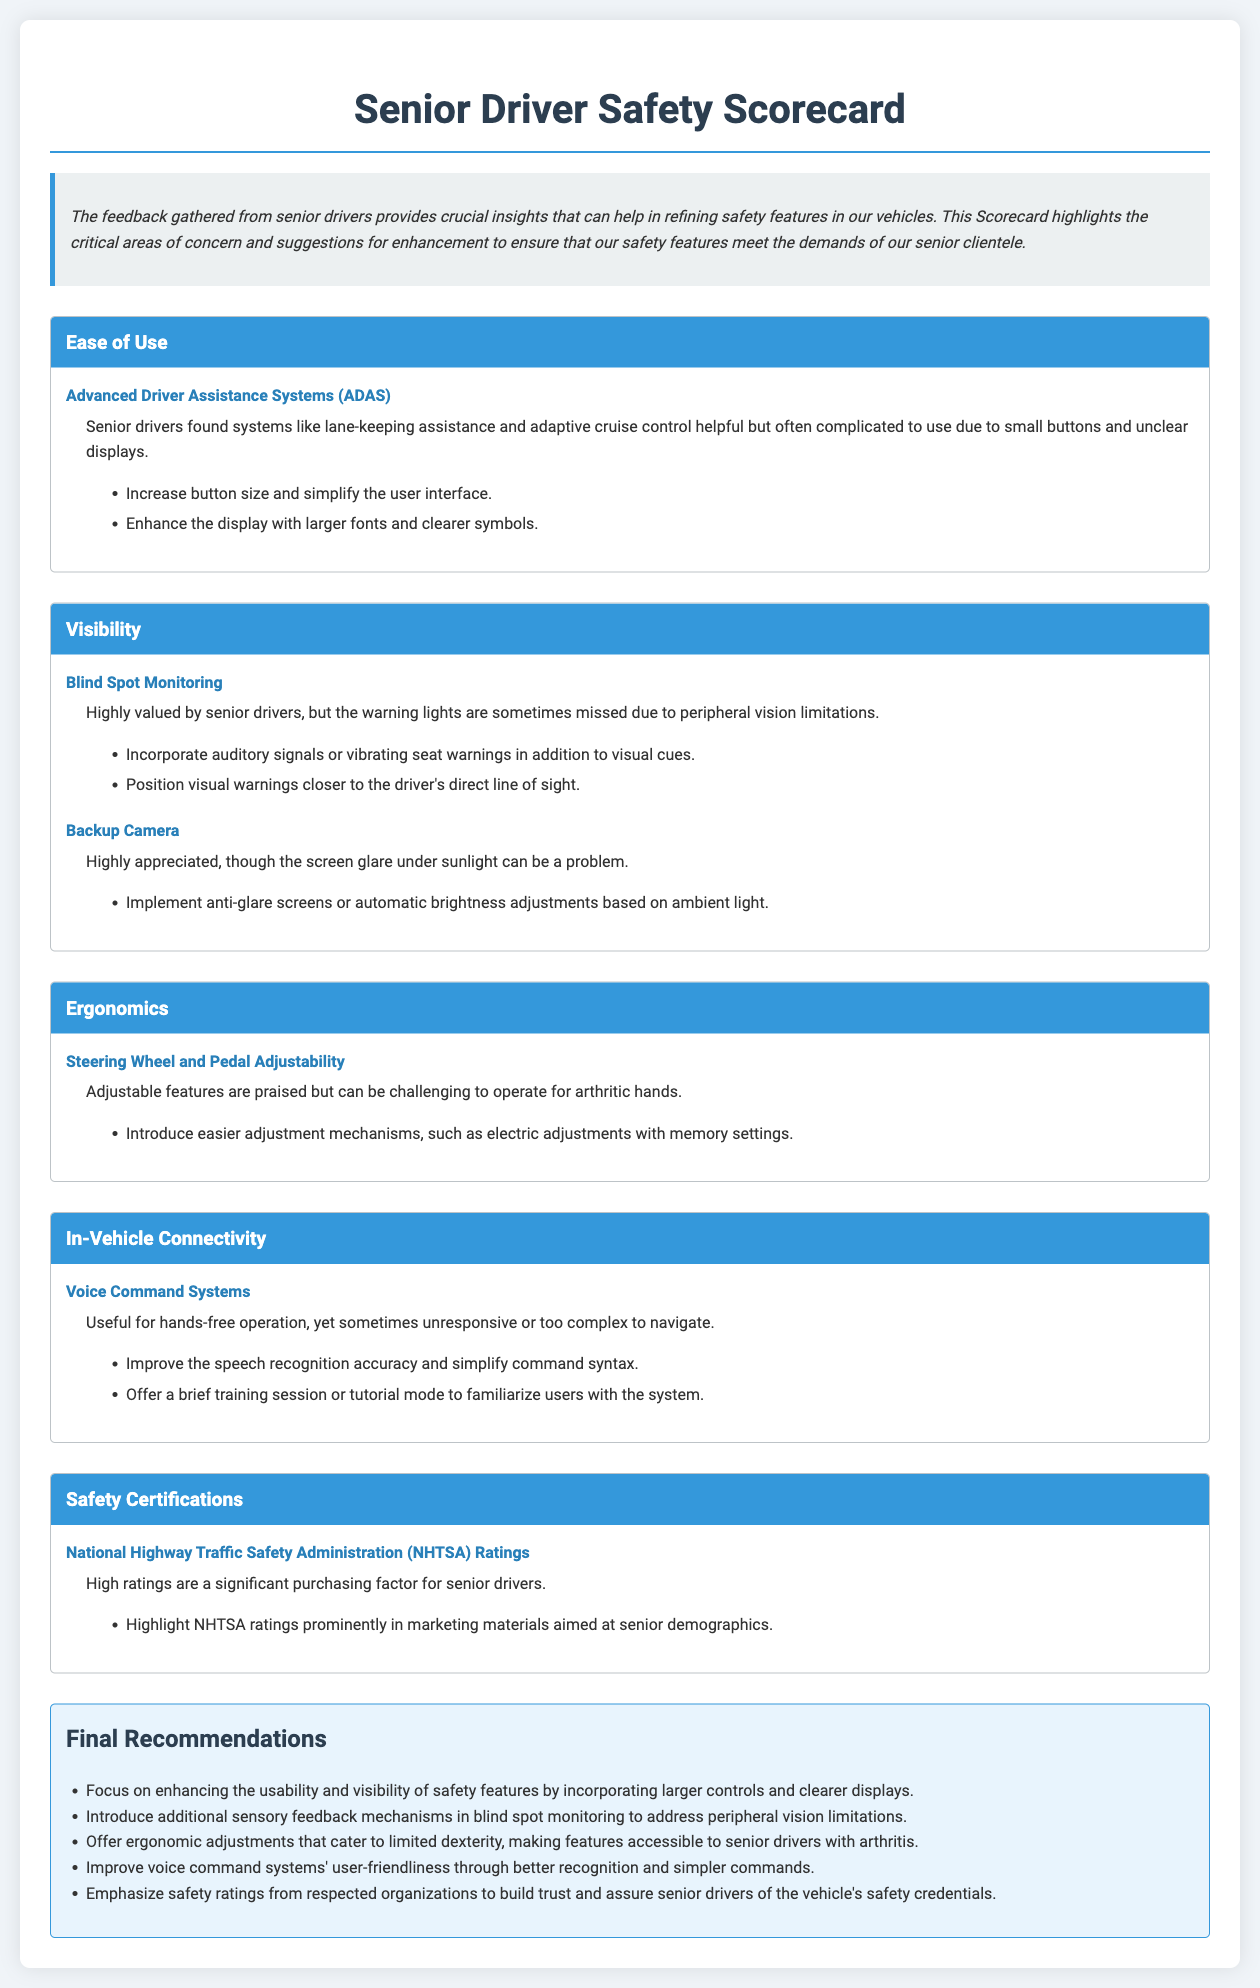what is the main purpose of the Scorecard? The purpose of the Scorecard is to highlight critical areas of concern and suggestions for enhancement to ensure that safety features meet the demands of senior clientele.
Answer: to refine safety features for senior clientele which safety feature received feedback regarding button size and display clarity? Advanced Driver Assistance Systems received feedback about the complexity of use due to small buttons and unclear displays.
Answer: Advanced Driver Assistance Systems what suggestion was made for Blind Spot Monitoring? A suggestion made was to incorporate auditory signals or vibrating seat warnings in addition to visual cues.
Answer: incorporate auditory signals or vibrating seat warnings how do senior drivers feel about the Backup Camera? Senior drivers highly appreciated the Backup Camera, despite the issue with screen glare under sunlight.
Answer: highly appreciated what is emphasized in the final recommendations regarding usability? The final recommendations emphasize enhancing the usability of safety features by incorporating larger controls and clearer displays.
Answer: larger controls and clearer displays how do senior drivers tend to view NHTSA ratings? High ratings are a significant purchasing factor for senior drivers.
Answer: significant purchasing factor what is one suggestion for adjusting the Steering Wheel and Pedal? One suggestion is to introduce easier adjustment mechanisms, such as electric adjustments with memory settings.
Answer: electric adjustments with memory settings which feature is noted for being useful for hands-free operation? Voice Command Systems are noted as useful for hands-free operation.
Answer: Voice Command Systems what is a key factor in purchasing decisions for senior drivers according to the document? High safety ratings from organizations like NHTSA is a key factor.
Answer: high safety ratings from NHTSA 